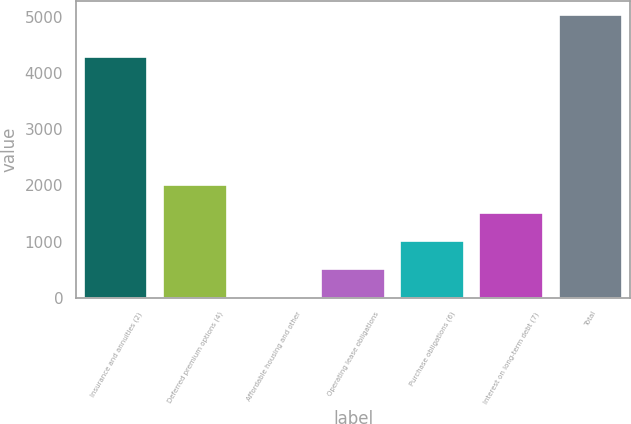Convert chart. <chart><loc_0><loc_0><loc_500><loc_500><bar_chart><fcel>Insurance and annuities (2)<fcel>Deferred premium options (4)<fcel>Affordable housing and other<fcel>Operating lease obligations<fcel>Purchase obligations (6)<fcel>Interest on long-term debt (7)<fcel>Total<nl><fcel>4294<fcel>2013.4<fcel>3<fcel>505.6<fcel>1008.2<fcel>1510.8<fcel>5029<nl></chart> 